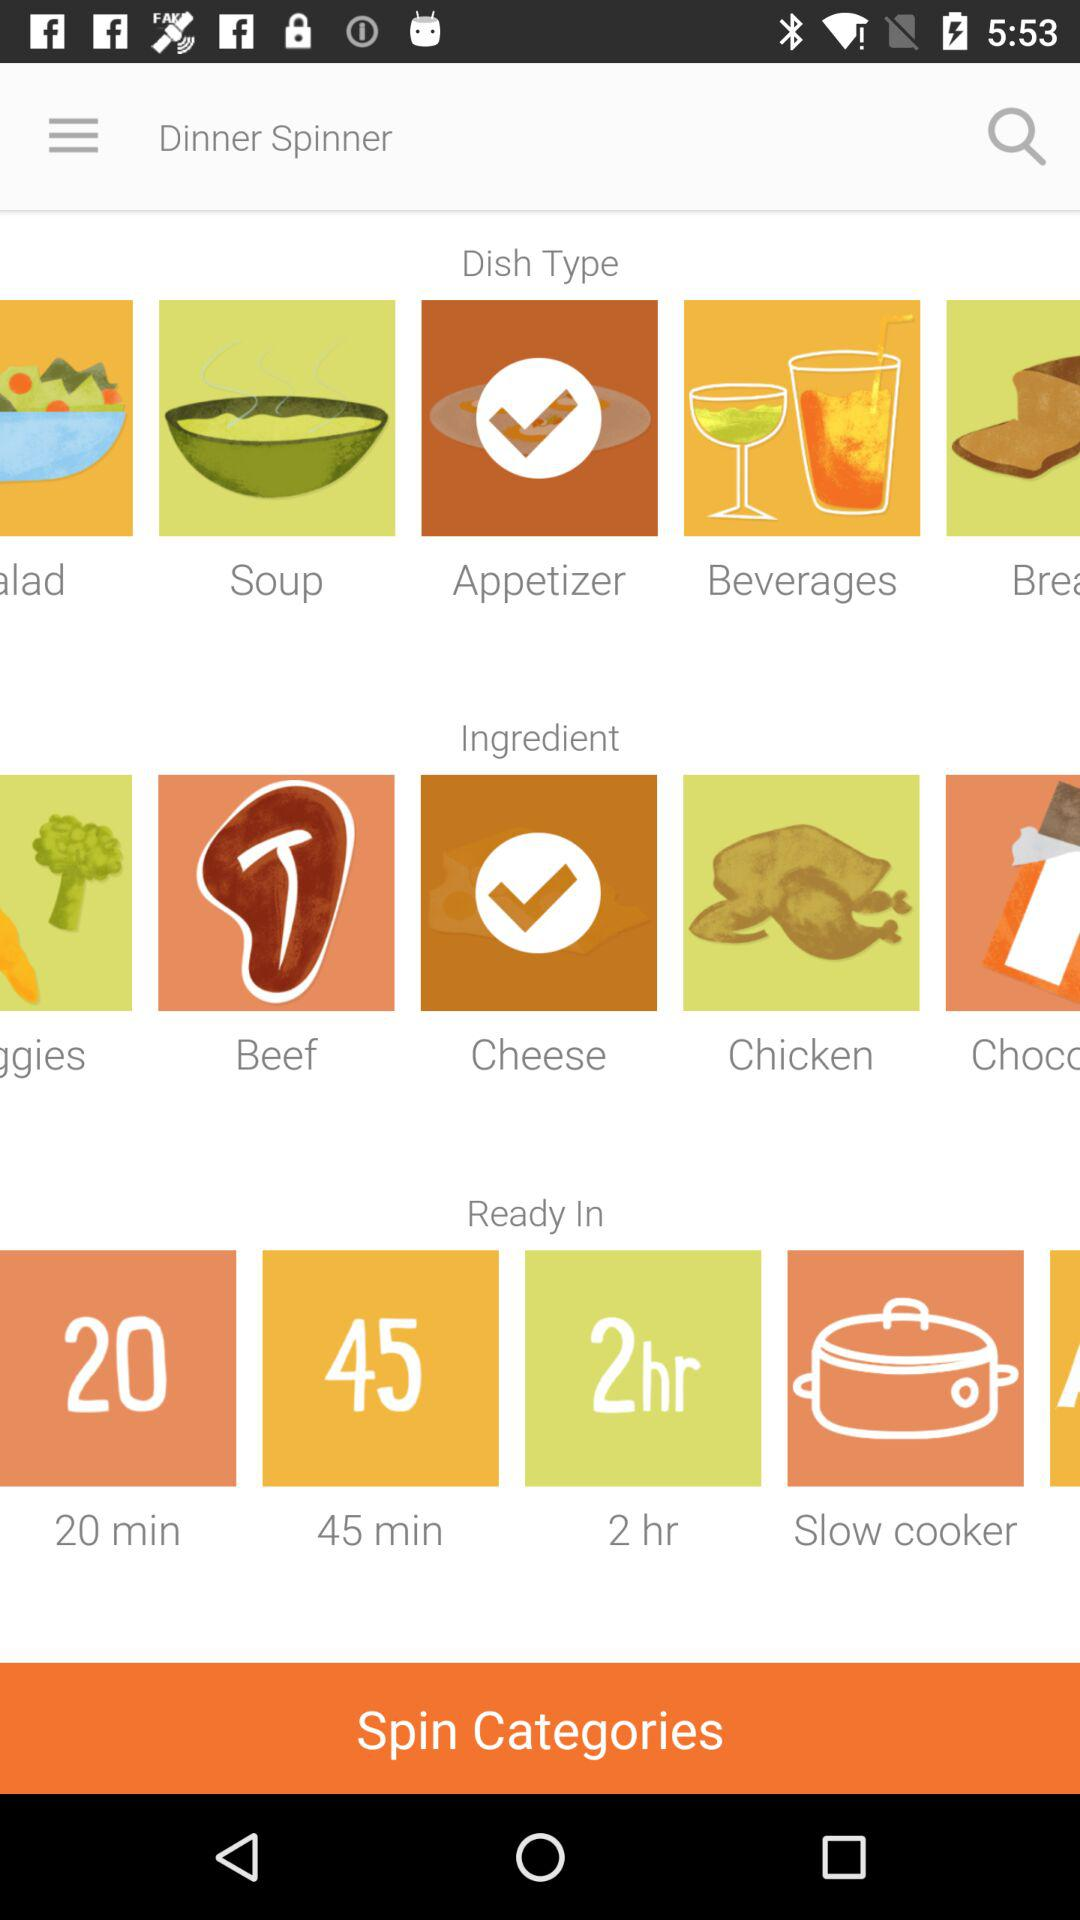Which is the selected ingredient? The selected ingredient is "Cheese". 